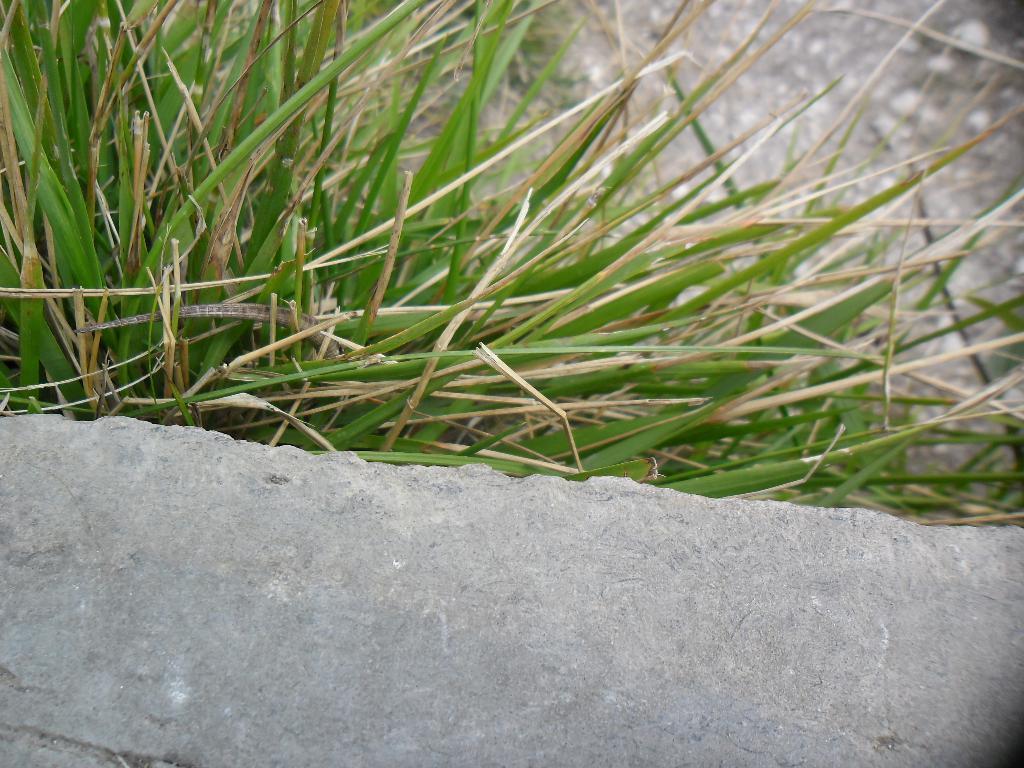How would you summarize this image in a sentence or two? In the picture I can see the grass and some other objects. The background of the image is blurred. 